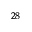Convert formula to latex. <formula><loc_0><loc_0><loc_500><loc_500>^ { 2 8 }</formula> 